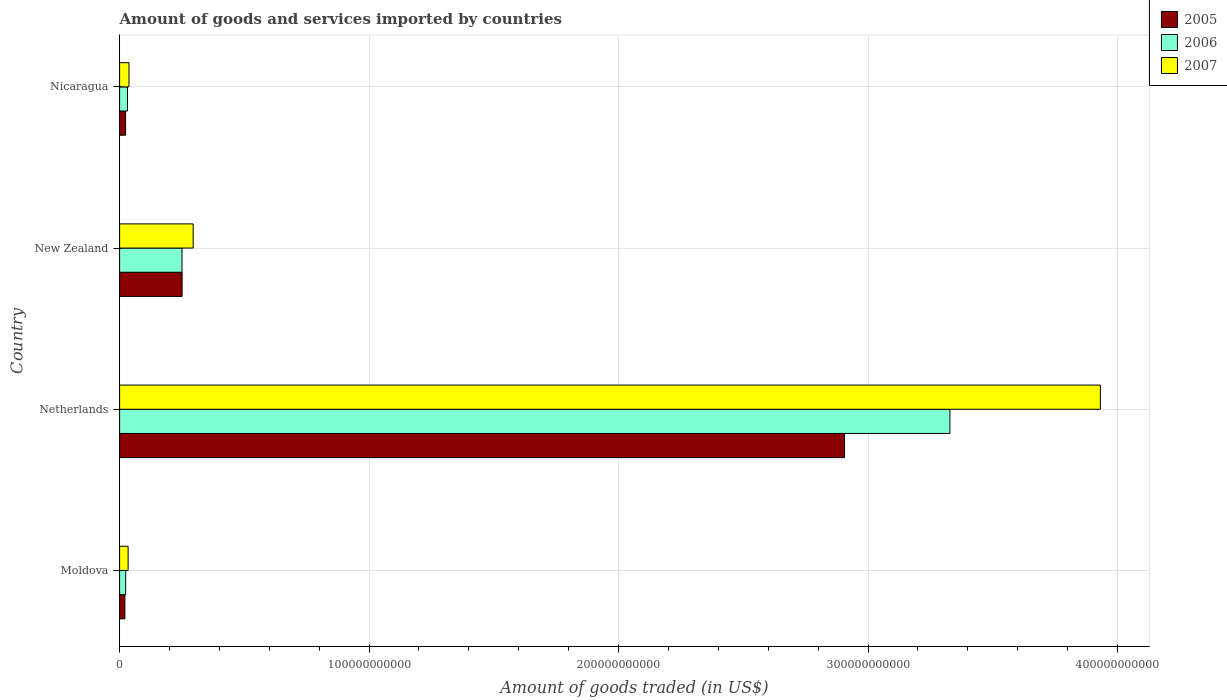How many different coloured bars are there?
Offer a very short reply. 3. How many bars are there on the 2nd tick from the top?
Your answer should be compact. 3. How many bars are there on the 1st tick from the bottom?
Provide a short and direct response. 3. What is the label of the 4th group of bars from the top?
Your answer should be compact. Moldova. What is the total amount of goods and services imported in 2005 in Nicaragua?
Provide a succinct answer. 2.40e+09. Across all countries, what is the maximum total amount of goods and services imported in 2007?
Provide a succinct answer. 3.93e+11. Across all countries, what is the minimum total amount of goods and services imported in 2005?
Ensure brevity in your answer.  2.12e+09. In which country was the total amount of goods and services imported in 2005 minimum?
Offer a terse response. Moldova. What is the total total amount of goods and services imported in 2007 in the graph?
Provide a succinct answer. 4.30e+11. What is the difference between the total amount of goods and services imported in 2007 in New Zealand and that in Nicaragua?
Provide a succinct answer. 2.57e+1. What is the difference between the total amount of goods and services imported in 2007 in Moldova and the total amount of goods and services imported in 2006 in Nicaragua?
Ensure brevity in your answer.  2.64e+08. What is the average total amount of goods and services imported in 2005 per country?
Ensure brevity in your answer.  8.00e+1. What is the difference between the total amount of goods and services imported in 2007 and total amount of goods and services imported in 2005 in New Zealand?
Provide a short and direct response. 4.43e+09. In how many countries, is the total amount of goods and services imported in 2006 greater than 140000000000 US$?
Offer a terse response. 1. What is the ratio of the total amount of goods and services imported in 2006 in Netherlands to that in New Zealand?
Your response must be concise. 13.31. Is the total amount of goods and services imported in 2005 in Moldova less than that in Nicaragua?
Make the answer very short. Yes. Is the difference between the total amount of goods and services imported in 2007 in Netherlands and New Zealand greater than the difference between the total amount of goods and services imported in 2005 in Netherlands and New Zealand?
Offer a very short reply. Yes. What is the difference between the highest and the second highest total amount of goods and services imported in 2007?
Make the answer very short. 3.64e+11. What is the difference between the highest and the lowest total amount of goods and services imported in 2006?
Provide a short and direct response. 3.30e+11. What does the 2nd bar from the bottom in New Zealand represents?
Provide a succinct answer. 2006. Is it the case that in every country, the sum of the total amount of goods and services imported in 2006 and total amount of goods and services imported in 2007 is greater than the total amount of goods and services imported in 2005?
Provide a succinct answer. Yes. Are all the bars in the graph horizontal?
Provide a succinct answer. Yes. What is the difference between two consecutive major ticks on the X-axis?
Keep it short and to the point. 1.00e+11. Does the graph contain any zero values?
Your answer should be very brief. No. Where does the legend appear in the graph?
Your answer should be very brief. Top right. What is the title of the graph?
Your answer should be very brief. Amount of goods and services imported by countries. Does "1967" appear as one of the legend labels in the graph?
Offer a terse response. No. What is the label or title of the X-axis?
Your response must be concise. Amount of goods traded (in US$). What is the label or title of the Y-axis?
Provide a succinct answer. Country. What is the Amount of goods traded (in US$) of 2005 in Moldova?
Provide a succinct answer. 2.12e+09. What is the Amount of goods traded (in US$) in 2006 in Moldova?
Provide a short and direct response. 2.43e+09. What is the Amount of goods traded (in US$) in 2007 in Moldova?
Your response must be concise. 3.41e+09. What is the Amount of goods traded (in US$) in 2005 in Netherlands?
Provide a succinct answer. 2.91e+11. What is the Amount of goods traded (in US$) in 2006 in Netherlands?
Your response must be concise. 3.33e+11. What is the Amount of goods traded (in US$) of 2007 in Netherlands?
Provide a succinct answer. 3.93e+11. What is the Amount of goods traded (in US$) in 2005 in New Zealand?
Provide a short and direct response. 2.51e+1. What is the Amount of goods traded (in US$) in 2006 in New Zealand?
Offer a terse response. 2.50e+1. What is the Amount of goods traded (in US$) in 2007 in New Zealand?
Ensure brevity in your answer.  2.95e+1. What is the Amount of goods traded (in US$) of 2005 in Nicaragua?
Make the answer very short. 2.40e+09. What is the Amount of goods traded (in US$) in 2006 in Nicaragua?
Offer a very short reply. 3.14e+09. What is the Amount of goods traded (in US$) of 2007 in Nicaragua?
Give a very brief answer. 3.76e+09. Across all countries, what is the maximum Amount of goods traded (in US$) in 2005?
Your answer should be compact. 2.91e+11. Across all countries, what is the maximum Amount of goods traded (in US$) of 2006?
Keep it short and to the point. 3.33e+11. Across all countries, what is the maximum Amount of goods traded (in US$) of 2007?
Provide a succinct answer. 3.93e+11. Across all countries, what is the minimum Amount of goods traded (in US$) of 2005?
Your response must be concise. 2.12e+09. Across all countries, what is the minimum Amount of goods traded (in US$) in 2006?
Your answer should be very brief. 2.43e+09. Across all countries, what is the minimum Amount of goods traded (in US$) in 2007?
Your answer should be compact. 3.41e+09. What is the total Amount of goods traded (in US$) of 2005 in the graph?
Ensure brevity in your answer.  3.20e+11. What is the total Amount of goods traded (in US$) of 2006 in the graph?
Make the answer very short. 3.63e+11. What is the total Amount of goods traded (in US$) of 2007 in the graph?
Give a very brief answer. 4.30e+11. What is the difference between the Amount of goods traded (in US$) in 2005 in Moldova and that in Netherlands?
Your answer should be very brief. -2.88e+11. What is the difference between the Amount of goods traded (in US$) in 2006 in Moldova and that in Netherlands?
Your answer should be very brief. -3.30e+11. What is the difference between the Amount of goods traded (in US$) of 2007 in Moldova and that in Netherlands?
Provide a short and direct response. -3.90e+11. What is the difference between the Amount of goods traded (in US$) in 2005 in Moldova and that in New Zealand?
Provide a short and direct response. -2.29e+1. What is the difference between the Amount of goods traded (in US$) in 2006 in Moldova and that in New Zealand?
Ensure brevity in your answer.  -2.26e+1. What is the difference between the Amount of goods traded (in US$) in 2007 in Moldova and that in New Zealand?
Your answer should be compact. -2.61e+1. What is the difference between the Amount of goods traded (in US$) in 2005 in Moldova and that in Nicaragua?
Your response must be concise. -2.86e+08. What is the difference between the Amount of goods traded (in US$) in 2006 in Moldova and that in Nicaragua?
Offer a terse response. -7.11e+08. What is the difference between the Amount of goods traded (in US$) of 2007 in Moldova and that in Nicaragua?
Offer a very short reply. -3.50e+08. What is the difference between the Amount of goods traded (in US$) of 2005 in Netherlands and that in New Zealand?
Keep it short and to the point. 2.66e+11. What is the difference between the Amount of goods traded (in US$) in 2006 in Netherlands and that in New Zealand?
Ensure brevity in your answer.  3.08e+11. What is the difference between the Amount of goods traded (in US$) in 2007 in Netherlands and that in New Zealand?
Ensure brevity in your answer.  3.64e+11. What is the difference between the Amount of goods traded (in US$) in 2005 in Netherlands and that in Nicaragua?
Offer a very short reply. 2.88e+11. What is the difference between the Amount of goods traded (in US$) of 2006 in Netherlands and that in Nicaragua?
Provide a short and direct response. 3.30e+11. What is the difference between the Amount of goods traded (in US$) in 2007 in Netherlands and that in Nicaragua?
Make the answer very short. 3.89e+11. What is the difference between the Amount of goods traded (in US$) of 2005 in New Zealand and that in Nicaragua?
Your response must be concise. 2.27e+1. What is the difference between the Amount of goods traded (in US$) of 2006 in New Zealand and that in Nicaragua?
Keep it short and to the point. 2.19e+1. What is the difference between the Amount of goods traded (in US$) of 2007 in New Zealand and that in Nicaragua?
Offer a very short reply. 2.57e+1. What is the difference between the Amount of goods traded (in US$) in 2005 in Moldova and the Amount of goods traded (in US$) in 2006 in Netherlands?
Offer a terse response. -3.31e+11. What is the difference between the Amount of goods traded (in US$) in 2005 in Moldova and the Amount of goods traded (in US$) in 2007 in Netherlands?
Ensure brevity in your answer.  -3.91e+11. What is the difference between the Amount of goods traded (in US$) of 2006 in Moldova and the Amount of goods traded (in US$) of 2007 in Netherlands?
Ensure brevity in your answer.  -3.91e+11. What is the difference between the Amount of goods traded (in US$) of 2005 in Moldova and the Amount of goods traded (in US$) of 2006 in New Zealand?
Offer a very short reply. -2.29e+1. What is the difference between the Amount of goods traded (in US$) of 2005 in Moldova and the Amount of goods traded (in US$) of 2007 in New Zealand?
Make the answer very short. -2.74e+1. What is the difference between the Amount of goods traded (in US$) in 2006 in Moldova and the Amount of goods traded (in US$) in 2007 in New Zealand?
Offer a very short reply. -2.71e+1. What is the difference between the Amount of goods traded (in US$) of 2005 in Moldova and the Amount of goods traded (in US$) of 2006 in Nicaragua?
Offer a very short reply. -1.03e+09. What is the difference between the Amount of goods traded (in US$) of 2005 in Moldova and the Amount of goods traded (in US$) of 2007 in Nicaragua?
Give a very brief answer. -1.64e+09. What is the difference between the Amount of goods traded (in US$) in 2006 in Moldova and the Amount of goods traded (in US$) in 2007 in Nicaragua?
Provide a succinct answer. -1.33e+09. What is the difference between the Amount of goods traded (in US$) of 2005 in Netherlands and the Amount of goods traded (in US$) of 2006 in New Zealand?
Offer a very short reply. 2.66e+11. What is the difference between the Amount of goods traded (in US$) of 2005 in Netherlands and the Amount of goods traded (in US$) of 2007 in New Zealand?
Your answer should be compact. 2.61e+11. What is the difference between the Amount of goods traded (in US$) in 2006 in Netherlands and the Amount of goods traded (in US$) in 2007 in New Zealand?
Provide a succinct answer. 3.03e+11. What is the difference between the Amount of goods traded (in US$) in 2005 in Netherlands and the Amount of goods traded (in US$) in 2006 in Nicaragua?
Your response must be concise. 2.87e+11. What is the difference between the Amount of goods traded (in US$) of 2005 in Netherlands and the Amount of goods traded (in US$) of 2007 in Nicaragua?
Keep it short and to the point. 2.87e+11. What is the difference between the Amount of goods traded (in US$) in 2006 in Netherlands and the Amount of goods traded (in US$) in 2007 in Nicaragua?
Your answer should be very brief. 3.29e+11. What is the difference between the Amount of goods traded (in US$) of 2005 in New Zealand and the Amount of goods traded (in US$) of 2006 in Nicaragua?
Your response must be concise. 2.19e+1. What is the difference between the Amount of goods traded (in US$) of 2005 in New Zealand and the Amount of goods traded (in US$) of 2007 in Nicaragua?
Make the answer very short. 2.13e+1. What is the difference between the Amount of goods traded (in US$) of 2006 in New Zealand and the Amount of goods traded (in US$) of 2007 in Nicaragua?
Offer a terse response. 2.12e+1. What is the average Amount of goods traded (in US$) in 2005 per country?
Your answer should be very brief. 8.00e+1. What is the average Amount of goods traded (in US$) of 2006 per country?
Keep it short and to the point. 9.09e+1. What is the average Amount of goods traded (in US$) in 2007 per country?
Keep it short and to the point. 1.07e+11. What is the difference between the Amount of goods traded (in US$) of 2005 and Amount of goods traded (in US$) of 2006 in Moldova?
Keep it short and to the point. -3.15e+08. What is the difference between the Amount of goods traded (in US$) in 2005 and Amount of goods traded (in US$) in 2007 in Moldova?
Offer a terse response. -1.29e+09. What is the difference between the Amount of goods traded (in US$) of 2006 and Amount of goods traded (in US$) of 2007 in Moldova?
Keep it short and to the point. -9.75e+08. What is the difference between the Amount of goods traded (in US$) in 2005 and Amount of goods traded (in US$) in 2006 in Netherlands?
Provide a short and direct response. -4.23e+1. What is the difference between the Amount of goods traded (in US$) in 2005 and Amount of goods traded (in US$) in 2007 in Netherlands?
Provide a succinct answer. -1.03e+11. What is the difference between the Amount of goods traded (in US$) of 2006 and Amount of goods traded (in US$) of 2007 in Netherlands?
Provide a short and direct response. -6.03e+1. What is the difference between the Amount of goods traded (in US$) of 2005 and Amount of goods traded (in US$) of 2006 in New Zealand?
Offer a terse response. 5.03e+07. What is the difference between the Amount of goods traded (in US$) of 2005 and Amount of goods traded (in US$) of 2007 in New Zealand?
Ensure brevity in your answer.  -4.43e+09. What is the difference between the Amount of goods traded (in US$) in 2006 and Amount of goods traded (in US$) in 2007 in New Zealand?
Your answer should be very brief. -4.48e+09. What is the difference between the Amount of goods traded (in US$) of 2005 and Amount of goods traded (in US$) of 2006 in Nicaragua?
Give a very brief answer. -7.40e+08. What is the difference between the Amount of goods traded (in US$) of 2005 and Amount of goods traded (in US$) of 2007 in Nicaragua?
Offer a very short reply. -1.35e+09. What is the difference between the Amount of goods traded (in US$) of 2006 and Amount of goods traded (in US$) of 2007 in Nicaragua?
Make the answer very short. -6.14e+08. What is the ratio of the Amount of goods traded (in US$) in 2005 in Moldova to that in Netherlands?
Offer a very short reply. 0.01. What is the ratio of the Amount of goods traded (in US$) of 2006 in Moldova to that in Netherlands?
Provide a short and direct response. 0.01. What is the ratio of the Amount of goods traded (in US$) in 2007 in Moldova to that in Netherlands?
Your response must be concise. 0.01. What is the ratio of the Amount of goods traded (in US$) in 2005 in Moldova to that in New Zealand?
Your answer should be compact. 0.08. What is the ratio of the Amount of goods traded (in US$) of 2006 in Moldova to that in New Zealand?
Provide a short and direct response. 0.1. What is the ratio of the Amount of goods traded (in US$) in 2007 in Moldova to that in New Zealand?
Provide a short and direct response. 0.12. What is the ratio of the Amount of goods traded (in US$) in 2005 in Moldova to that in Nicaragua?
Your answer should be compact. 0.88. What is the ratio of the Amount of goods traded (in US$) in 2006 in Moldova to that in Nicaragua?
Offer a very short reply. 0.77. What is the ratio of the Amount of goods traded (in US$) of 2007 in Moldova to that in Nicaragua?
Give a very brief answer. 0.91. What is the ratio of the Amount of goods traded (in US$) of 2005 in Netherlands to that in New Zealand?
Give a very brief answer. 11.6. What is the ratio of the Amount of goods traded (in US$) in 2006 in Netherlands to that in New Zealand?
Provide a succinct answer. 13.31. What is the ratio of the Amount of goods traded (in US$) in 2007 in Netherlands to that in New Zealand?
Provide a succinct answer. 13.33. What is the ratio of the Amount of goods traded (in US$) of 2005 in Netherlands to that in Nicaragua?
Keep it short and to the point. 120.84. What is the ratio of the Amount of goods traded (in US$) of 2006 in Netherlands to that in Nicaragua?
Your response must be concise. 105.83. What is the ratio of the Amount of goods traded (in US$) of 2007 in Netherlands to that in Nicaragua?
Make the answer very short. 104.58. What is the ratio of the Amount of goods traded (in US$) in 2005 in New Zealand to that in Nicaragua?
Give a very brief answer. 10.42. What is the ratio of the Amount of goods traded (in US$) in 2006 in New Zealand to that in Nicaragua?
Provide a succinct answer. 7.95. What is the ratio of the Amount of goods traded (in US$) of 2007 in New Zealand to that in Nicaragua?
Ensure brevity in your answer.  7.84. What is the difference between the highest and the second highest Amount of goods traded (in US$) in 2005?
Give a very brief answer. 2.66e+11. What is the difference between the highest and the second highest Amount of goods traded (in US$) in 2006?
Provide a short and direct response. 3.08e+11. What is the difference between the highest and the second highest Amount of goods traded (in US$) of 2007?
Provide a short and direct response. 3.64e+11. What is the difference between the highest and the lowest Amount of goods traded (in US$) of 2005?
Your answer should be very brief. 2.88e+11. What is the difference between the highest and the lowest Amount of goods traded (in US$) in 2006?
Your answer should be compact. 3.30e+11. What is the difference between the highest and the lowest Amount of goods traded (in US$) in 2007?
Your response must be concise. 3.90e+11. 